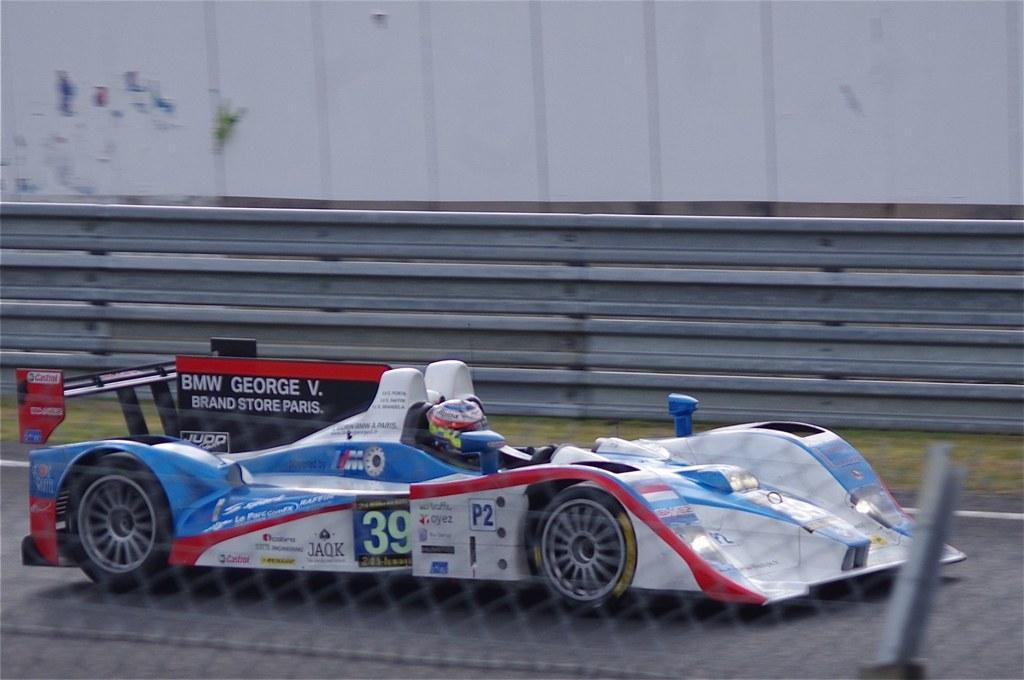Describe this image in one or two sentences. In this image we can see one person driving a car on the road, one fence with pole, some green grass on the side of the road, one big white wall and one object on the surface. 